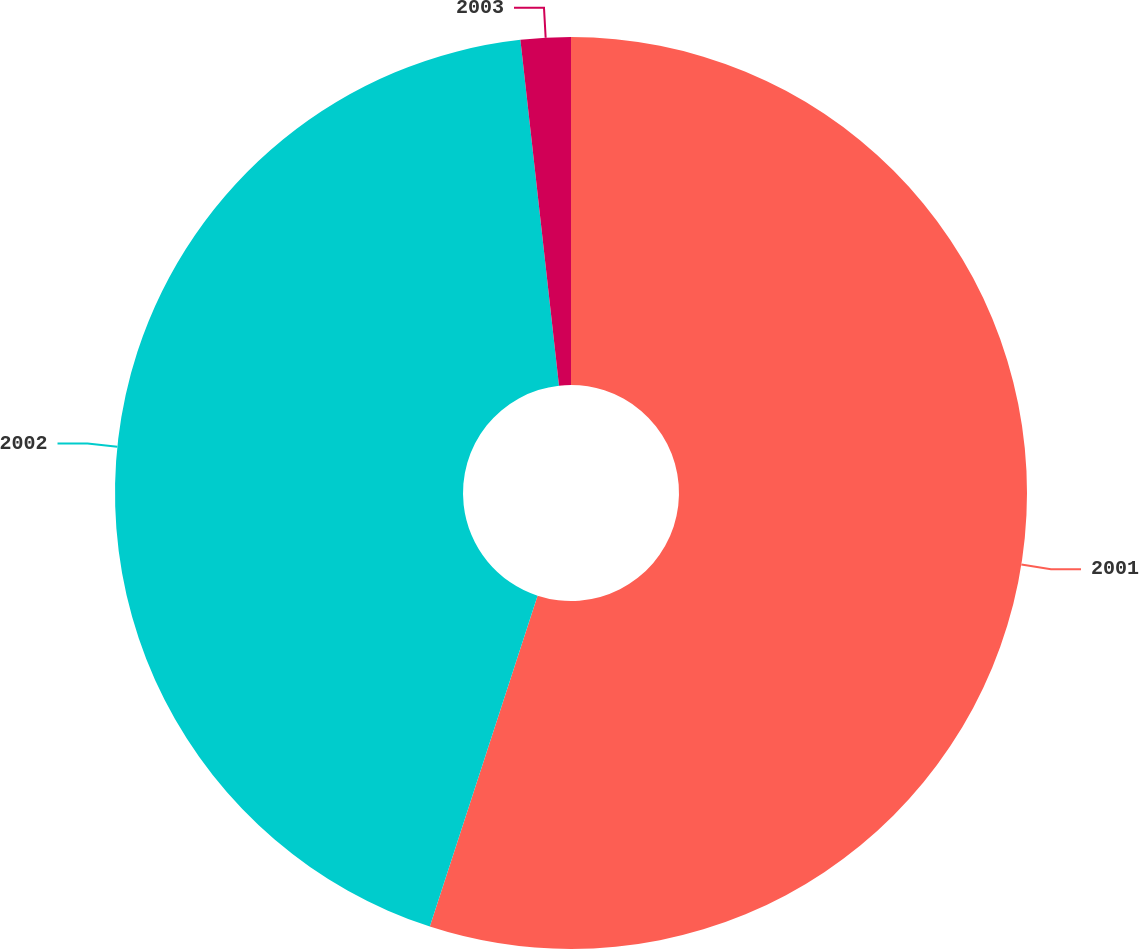Convert chart to OTSL. <chart><loc_0><loc_0><loc_500><loc_500><pie_chart><fcel>2001<fcel>2002<fcel>2003<nl><fcel>55.01%<fcel>43.22%<fcel>1.77%<nl></chart> 